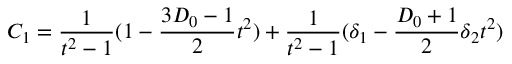Convert formula to latex. <formula><loc_0><loc_0><loc_500><loc_500>C _ { 1 } = \frac { 1 } { t ^ { 2 } - 1 } ( 1 - \frac { 3 D _ { 0 } - 1 } { 2 } t ^ { 2 } ) + \frac { 1 } { t ^ { 2 } - 1 } ( \delta _ { 1 } - \frac { D _ { 0 } + 1 } { 2 } \delta _ { 2 } t ^ { 2 } )</formula> 